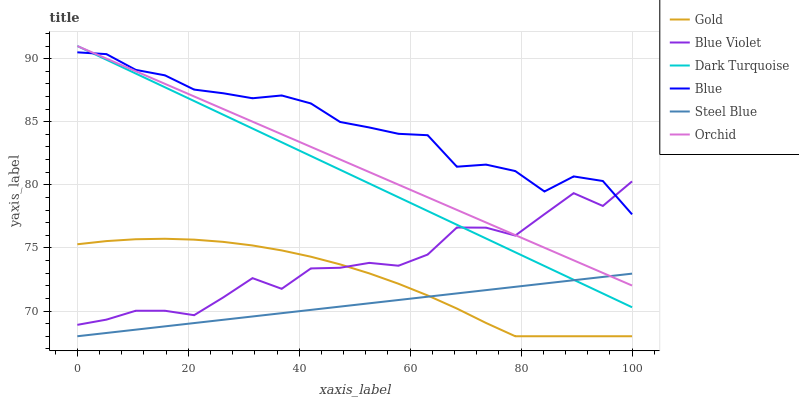Does Steel Blue have the minimum area under the curve?
Answer yes or no. Yes. Does Blue have the maximum area under the curve?
Answer yes or no. Yes. Does Gold have the minimum area under the curve?
Answer yes or no. No. Does Gold have the maximum area under the curve?
Answer yes or no. No. Is Dark Turquoise the smoothest?
Answer yes or no. Yes. Is Blue Violet the roughest?
Answer yes or no. Yes. Is Gold the smoothest?
Answer yes or no. No. Is Gold the roughest?
Answer yes or no. No. Does Gold have the lowest value?
Answer yes or no. Yes. Does Dark Turquoise have the lowest value?
Answer yes or no. No. Does Orchid have the highest value?
Answer yes or no. Yes. Does Gold have the highest value?
Answer yes or no. No. Is Gold less than Dark Turquoise?
Answer yes or no. Yes. Is Blue greater than Steel Blue?
Answer yes or no. Yes. Does Dark Turquoise intersect Orchid?
Answer yes or no. Yes. Is Dark Turquoise less than Orchid?
Answer yes or no. No. Is Dark Turquoise greater than Orchid?
Answer yes or no. No. Does Gold intersect Dark Turquoise?
Answer yes or no. No. 